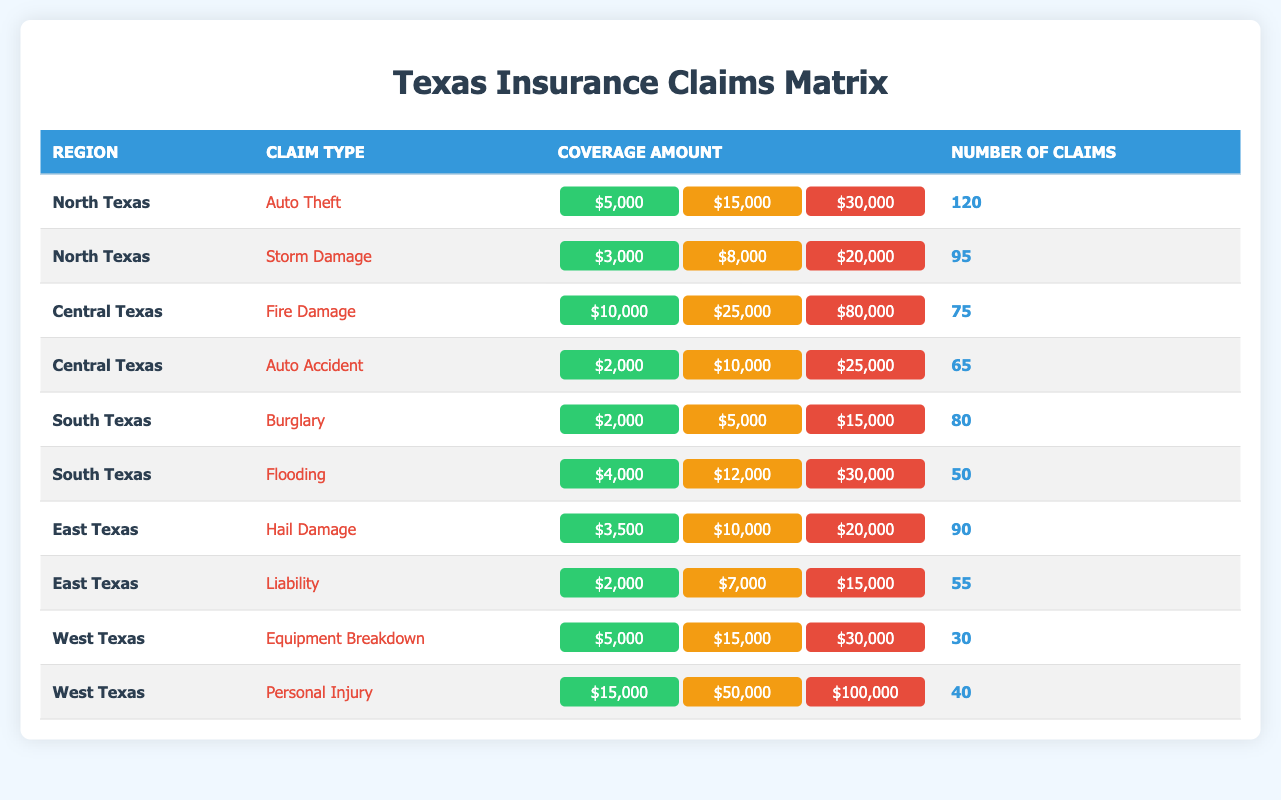What is the number of claims for Auto Theft in North Texas? The table indicates that for the claim type Auto Theft in the North Texas region, the number of claims is specifically listed as 120.
Answer: 120 What is the maximum coverage amount for Hail Damage in East Texas? The maximum coverage amount for the claim type Hail Damage in East Texas is found under the "High" category, which shows a value of 20000.
Answer: 20000 How many claims were filed for Fire Damage in Central Texas compared to Auto Accident? The number of claims for Fire Damage is 75 and for Auto Accident is 65. To compare, we can see that 75 (Fire Damage) is more than 65 (Auto Accident) by 10 claims.
Answer: 10 What is the total number of claims from South Texas? The claims from South Texas are listed as Burglary (80 claims) and Flooding (50 claims). Adding both amounts gives us 80 + 50 = 130 claims.
Answer: 130 Is the coverage amount for Equipment Breakdown the same as for Auto Theft? For Equipment Breakdown, the low coverage amount is 5000, the medium is 15000, and the high is 30000. For Auto Theft, the amounts are the same: low 5000, medium 15000, and high 30000. Since both claim types have identical coverage amounts, the statement is true.
Answer: Yes Which claim type has the highest number of claims, and what is that number? The claim types with the highest number of claims in the table are Auto Theft with 120 claims. This is confirmed by checking all rows for the number of claims and finding no other claim type exceeds this number.
Answer: 120 What is the average number of claims for all claim types in East Texas? The total number of claims in East Texas is for Hail Damage (90 claims) and Liability (55 claims) adding up to 145 claims. There are two claim types, so dividing gives us 145 / 2 = 72.5.
Answer: 72.5 Which region had the least number of claims for a single claim type? Looking at the table, West Texas has the claim type Equipment Breakdown with the least number of claims, standing at 30. Upon reviewing the entire table, no other claim type has less than this number.
Answer: 30 How many claims are there for Flooding compared to Storm Damage? The number of claims for Flooding is 50, and for Storm Damage, it is 95. To compare, there are 95 - 50 = 45 more claims for Storm Damage than for Flooding.
Answer: 45 